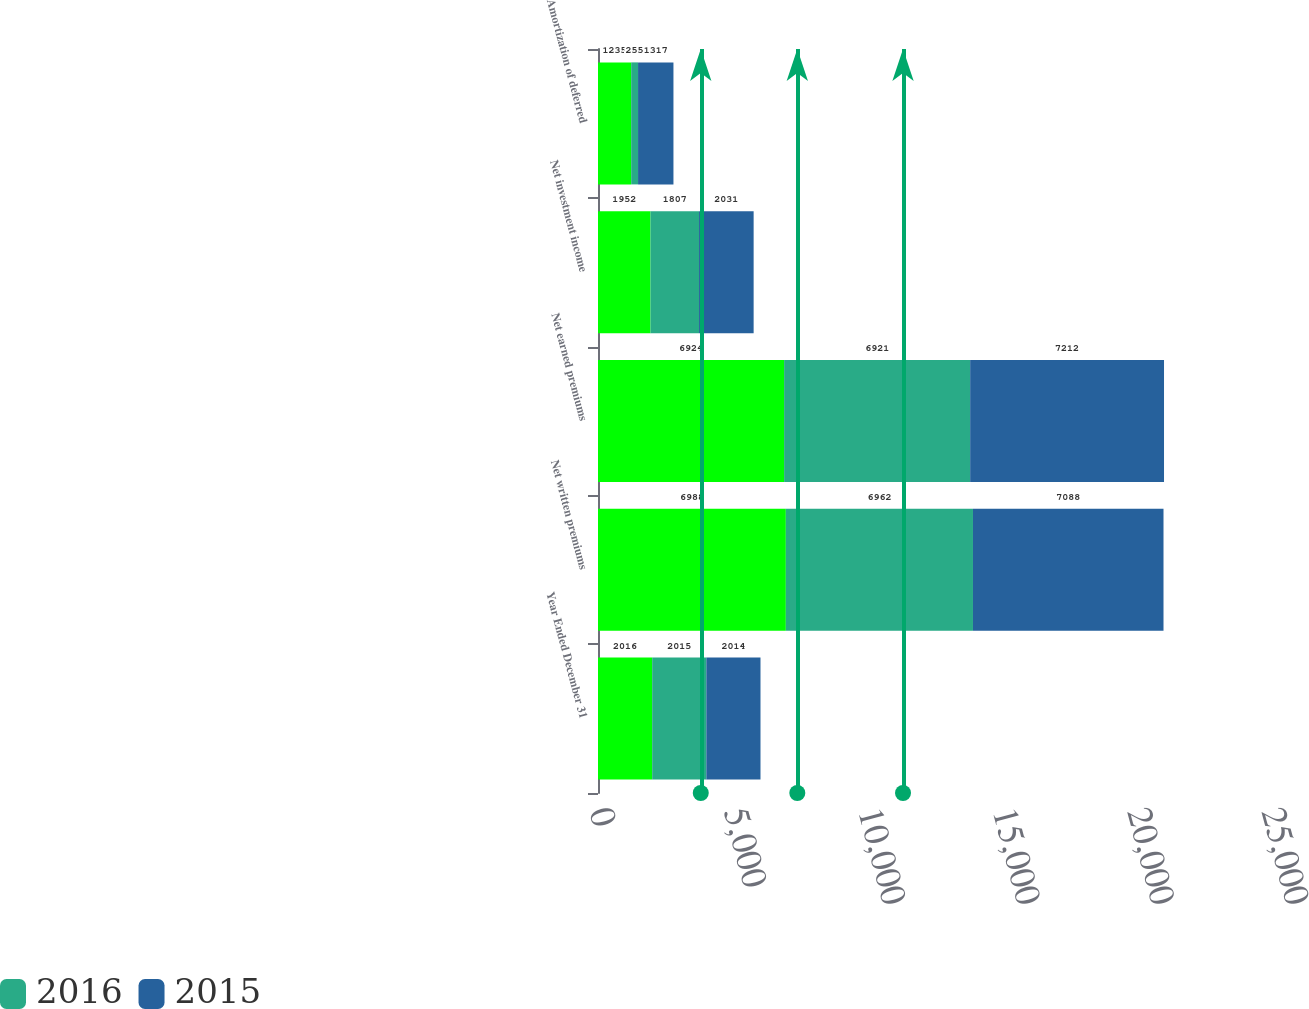Convert chart to OTSL. <chart><loc_0><loc_0><loc_500><loc_500><stacked_bar_chart><ecel><fcel>Year Ended December 31<fcel>Net written premiums<fcel>Net earned premiums<fcel>Net investment income<fcel>Amortization of deferred<nl><fcel>nan<fcel>2016<fcel>6988<fcel>6924<fcel>1952<fcel>1235<nl><fcel>2016<fcel>2015<fcel>6962<fcel>6921<fcel>1807<fcel>255<nl><fcel>2015<fcel>2014<fcel>7088<fcel>7212<fcel>2031<fcel>1317<nl></chart> 